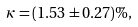Convert formula to latex. <formula><loc_0><loc_0><loc_500><loc_500>\kappa = ( 1 . 5 3 \pm 0 . 2 7 ) \% ,</formula> 